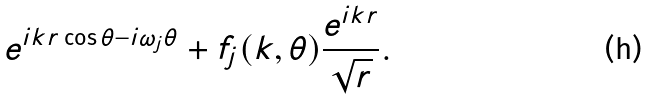<formula> <loc_0><loc_0><loc_500><loc_500>e ^ { i k r \cos \theta - i \omega _ { j } \theta } + f _ { j } ( k , \theta ) \frac { e ^ { i k r } } { \sqrt { r } } .</formula> 